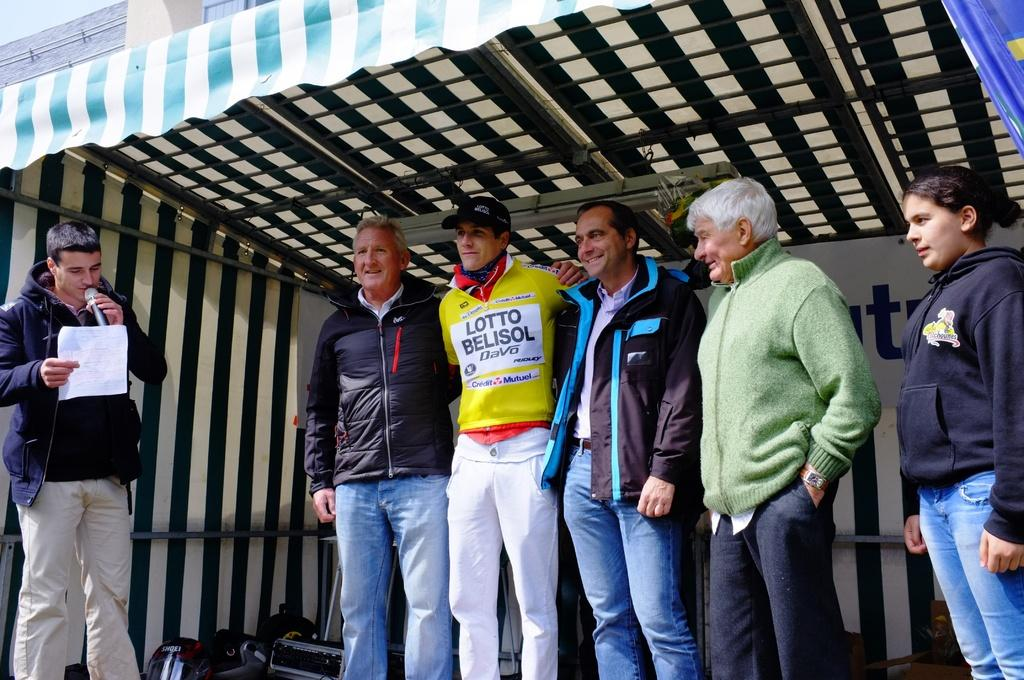<image>
Describe the image concisely. A man wearing a Lotto Belisol jersey stands on a stage surrounded by other men while another man reads of a sheet holding a microphone. 